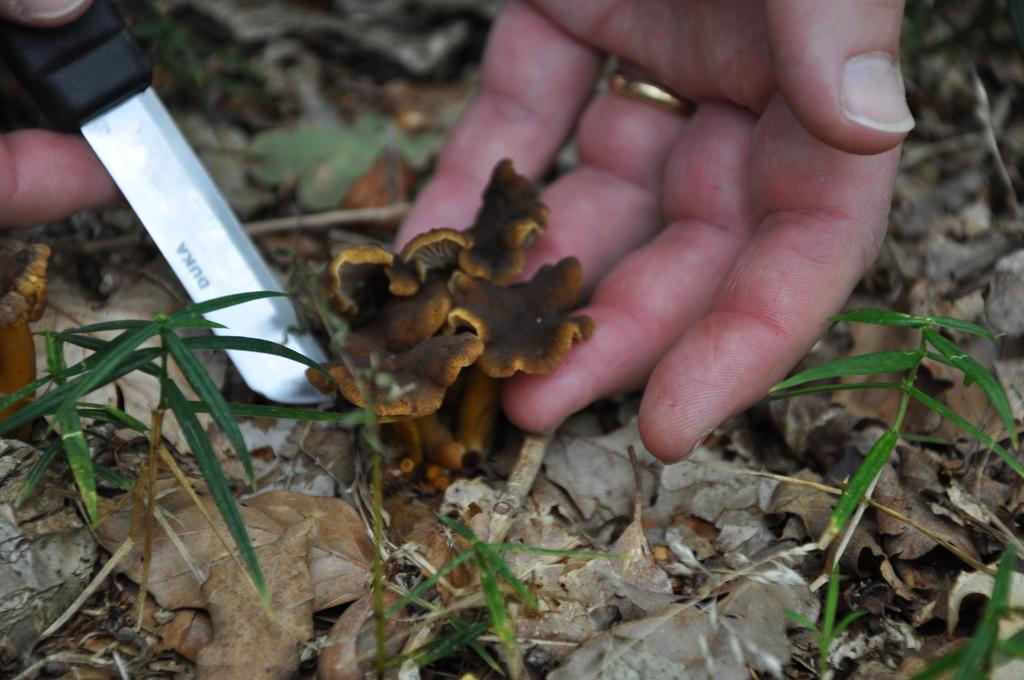What can be seen in the image that belongs to a person? There is a person's hand in the image. What is the hand holding? The hand is holding a mushroom. What is happening to the mushroom? The mushroom is being cut. What type of vegetation is visible at the bottom of the image? There is grass at the bottom of the image. What is the cause of the mushroom's movement in the image? The mushroom is not moving in the image; it is being held and cut by a person's hand. 